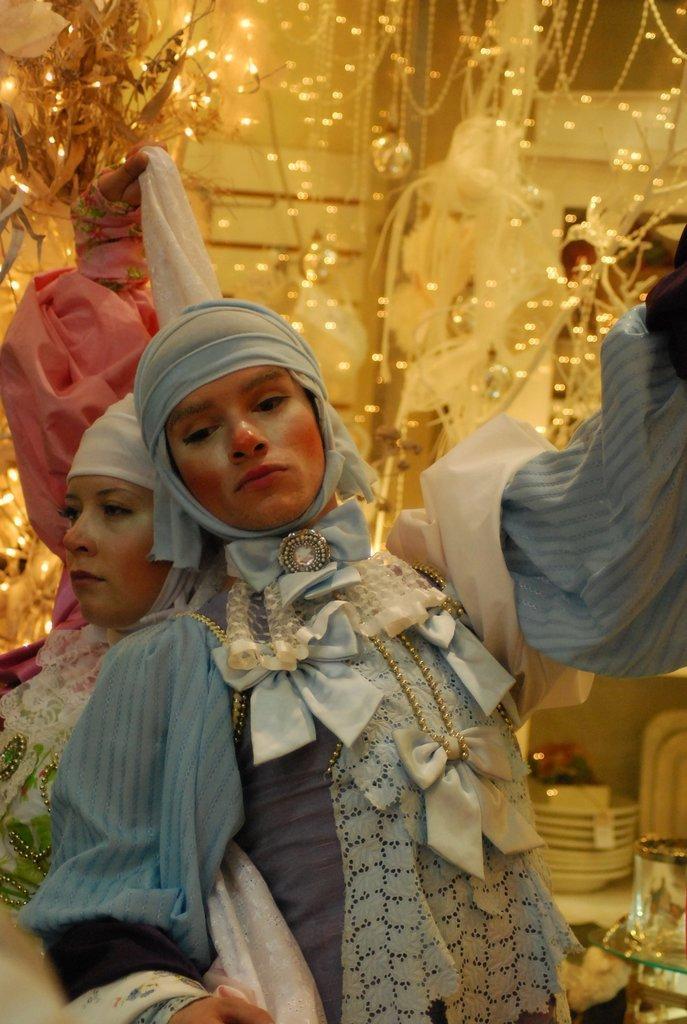Please provide a concise description of this image. There are two persons dancing as we can see in the middle of this image. There is a decoration with lights and a wall in the background. 